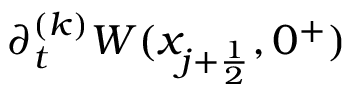Convert formula to latex. <formula><loc_0><loc_0><loc_500><loc_500>\partial _ { t } ^ { ( k ) } W ( x _ { j + \frac { 1 } { 2 } } , 0 ^ { + } )</formula> 